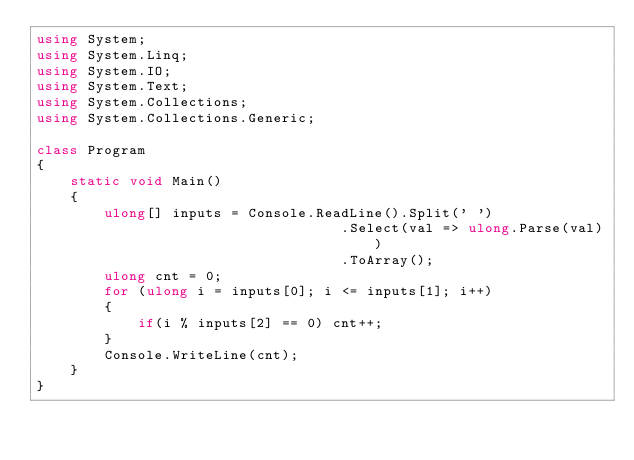Convert code to text. <code><loc_0><loc_0><loc_500><loc_500><_C#_>using System;
using System.Linq;
using System.IO;
using System.Text;
using System.Collections;
using System.Collections.Generic;
 
class Program
{
    static void Main()
    {
        ulong[] inputs = Console.ReadLine().Split(' ')
                                    .Select(val => ulong.Parse(val))
                                    .ToArray();
        ulong cnt = 0;
        for (ulong i = inputs[0]; i <= inputs[1]; i++)
        {
            if(i % inputs[2] == 0) cnt++;
        }
        Console.WriteLine(cnt);
    }
}
</code> 